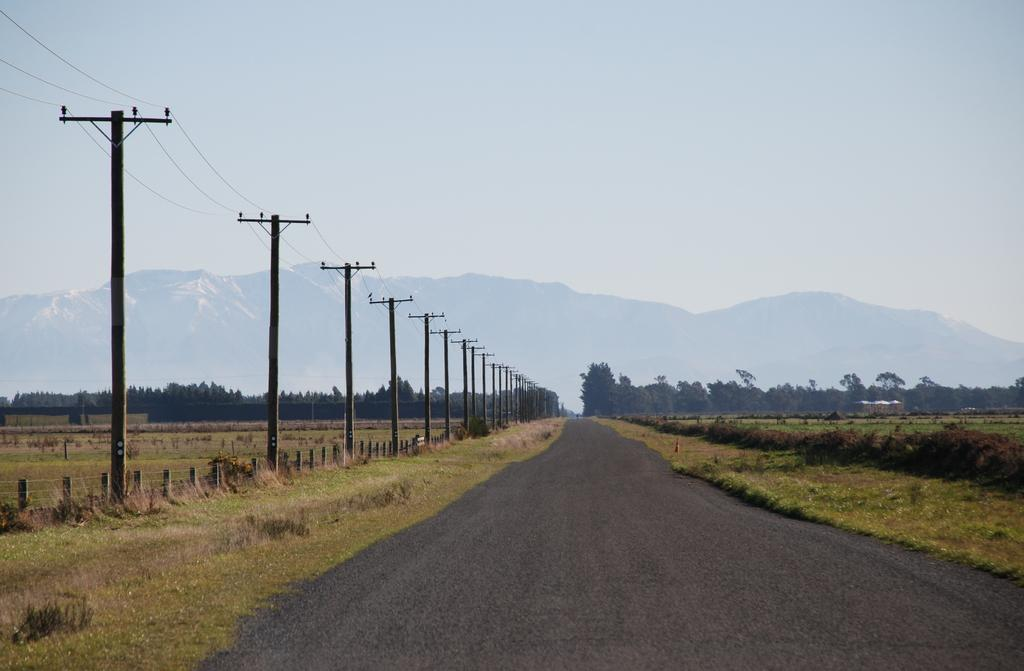What is the main feature of the image? There is a road in the image. What can be seen on either side of the road? There is grassland on either side of the road. What structures are present on the left side of the road? There are current poles on the left side of the road. What is visible in the background of the image? There are trees and a mountain in the background of the image. What type of bean is growing in a circle on the road in the image? There are no beans or circles present on the road in the image. 